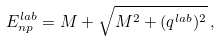Convert formula to latex. <formula><loc_0><loc_0><loc_500><loc_500>E _ { n p } ^ { l a b } = M + \sqrt { M ^ { 2 } + ( q ^ { l a b } ) ^ { 2 } } \, ,</formula> 